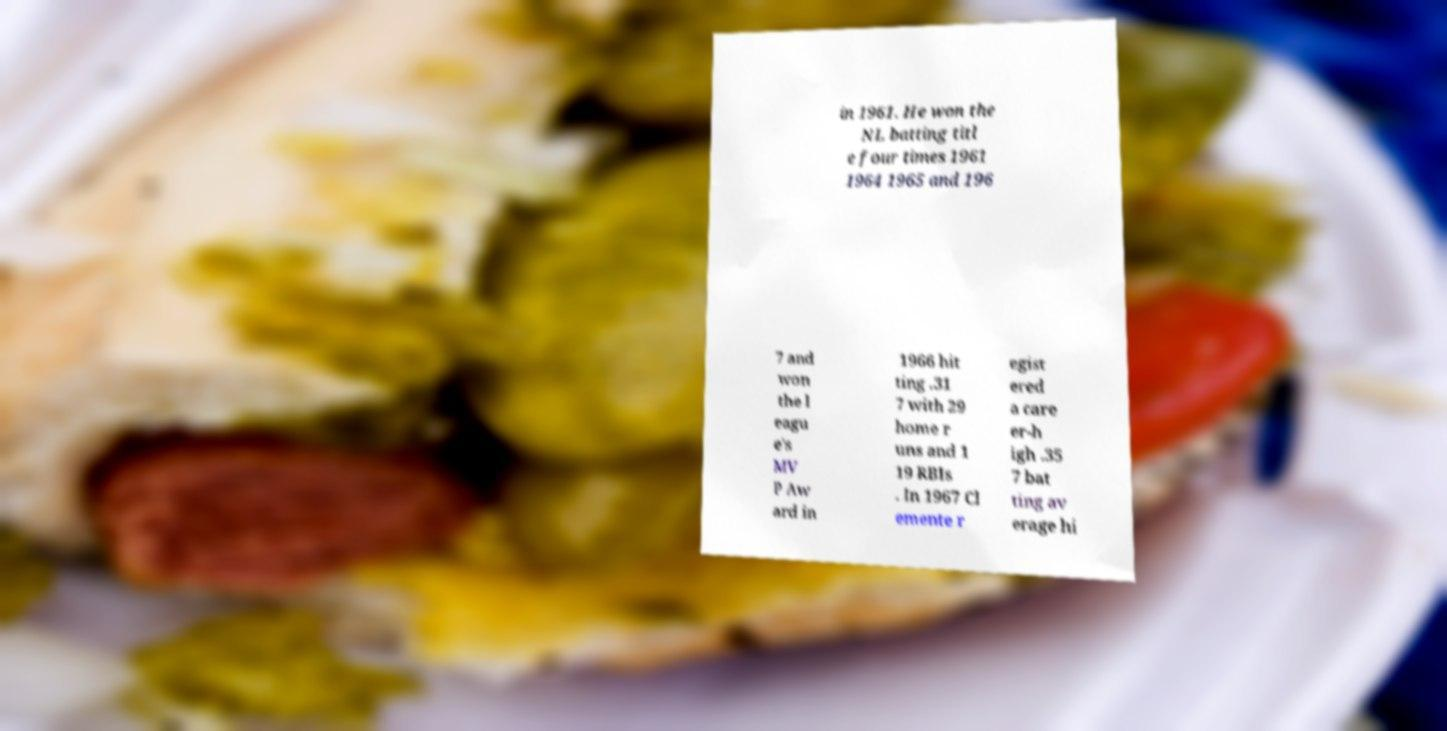Can you read and provide the text displayed in the image?This photo seems to have some interesting text. Can you extract and type it out for me? in 1961. He won the NL batting titl e four times 1961 1964 1965 and 196 7 and won the l eagu e's MV P Aw ard in 1966 hit ting .31 7 with 29 home r uns and 1 19 RBIs . In 1967 Cl emente r egist ered a care er-h igh .35 7 bat ting av erage hi 